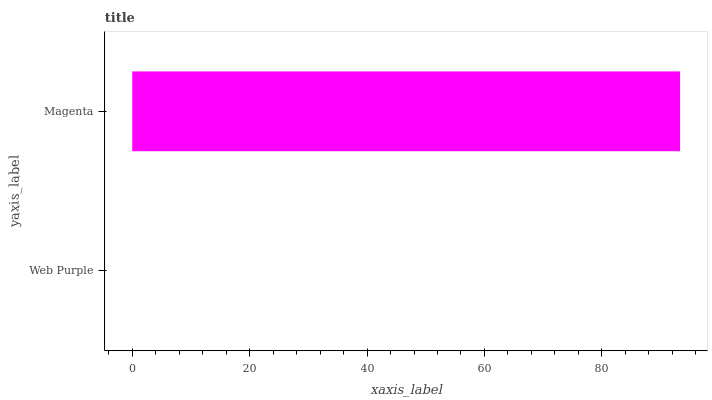Is Web Purple the minimum?
Answer yes or no. Yes. Is Magenta the maximum?
Answer yes or no. Yes. Is Magenta the minimum?
Answer yes or no. No. Is Magenta greater than Web Purple?
Answer yes or no. Yes. Is Web Purple less than Magenta?
Answer yes or no. Yes. Is Web Purple greater than Magenta?
Answer yes or no. No. Is Magenta less than Web Purple?
Answer yes or no. No. Is Magenta the high median?
Answer yes or no. Yes. Is Web Purple the low median?
Answer yes or no. Yes. Is Web Purple the high median?
Answer yes or no. No. Is Magenta the low median?
Answer yes or no. No. 